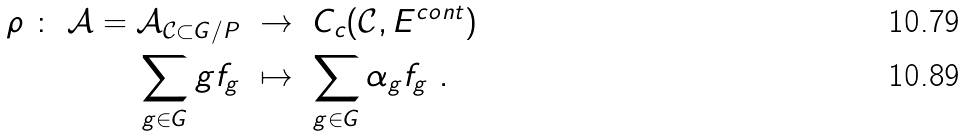Convert formula to latex. <formula><loc_0><loc_0><loc_500><loc_500>\rho \ \colon \ \mathcal { A } = \mathcal { A } _ { \mathcal { C } \subset G / P } & \ \to \ C _ { c } ( \mathcal { C } , E ^ { c o n t } ) \\ \sum _ { g \in G } g f _ { g } & \ \mapsto \ \sum _ { g \in G } \alpha _ { g } f _ { g } \ .</formula> 